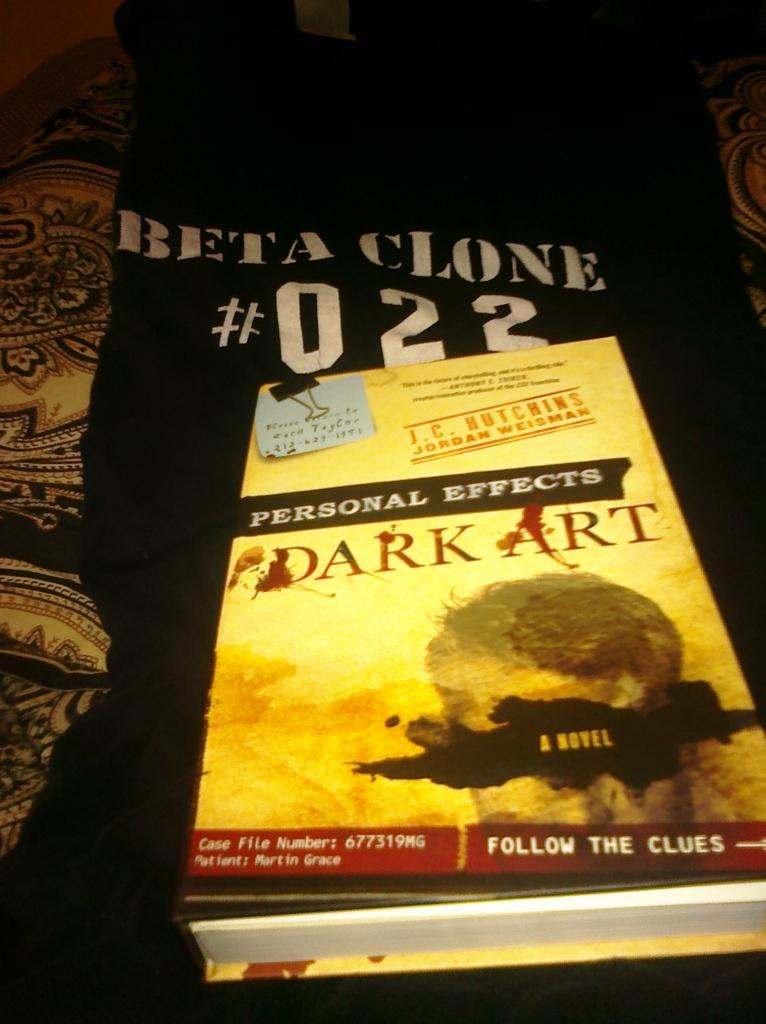<image>
Write a terse but informative summary of the picture. A book called Dark Art is laying on a black shirt that says Beta Clone #022. 